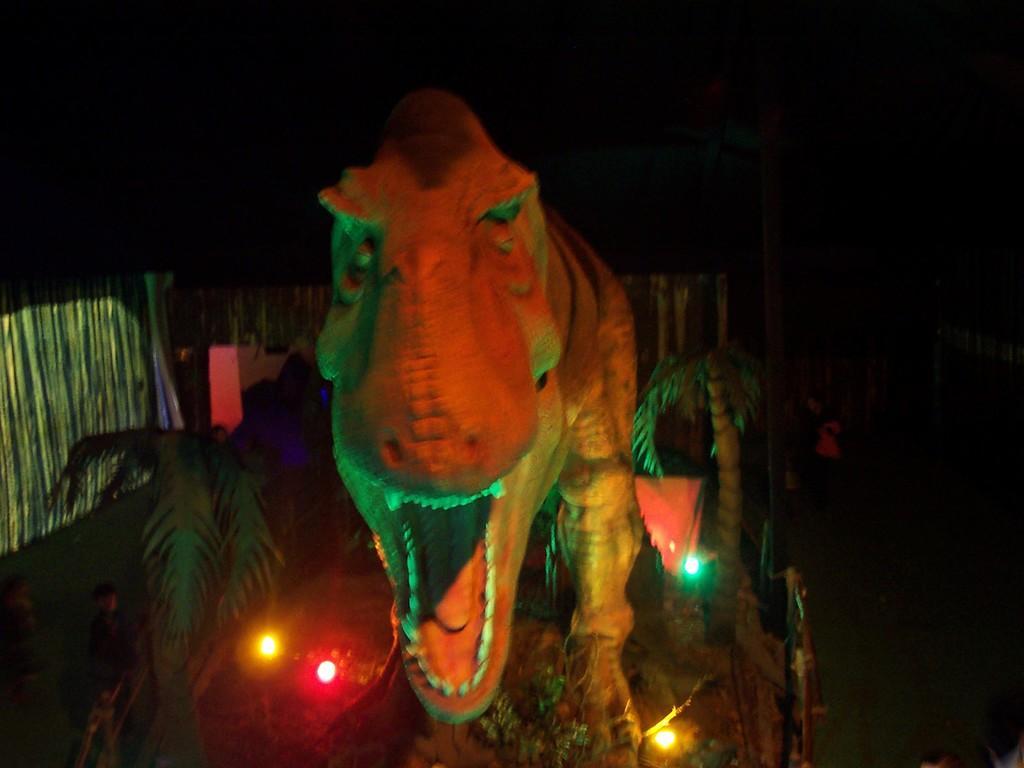Could you give a brief overview of what you see in this image? In this image there is a statue of a dinosaur. On the ground there are lights. On both sides there are plants. In the background there is a building. 